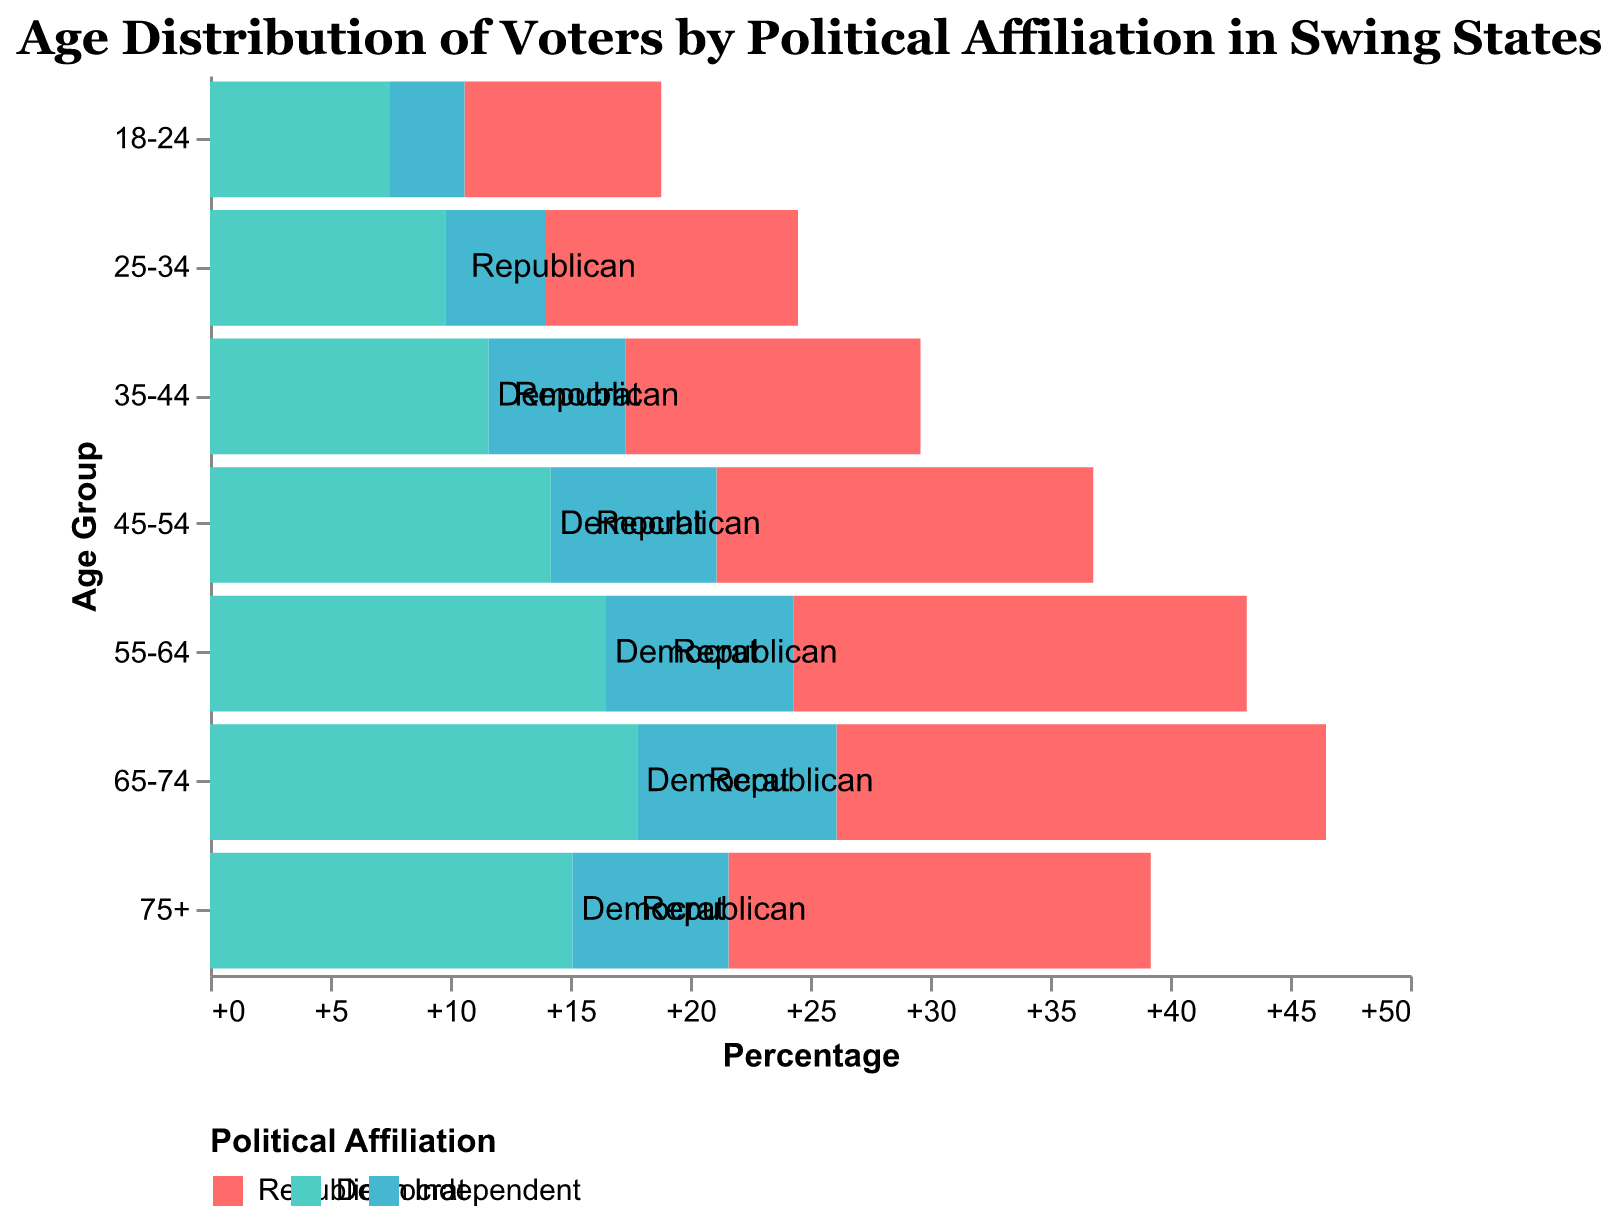What is the title of the graph? The title is displayed at the top of the graph. It clearly states the focus of the graph.
Answer: Age Distribution of Voters by Political Affiliation in Swing States What age group has the highest percentage of Republican voters? By examining the bar lengths representing Republicans, the length of the bar for the age group 65-74 is the longest.
Answer: 65-74 What age group has the lowest percentage of Democrat voters? By examining the bar lengths representing Democrats, the length of the bar for the age group 18-24 is the shortest.
Answer: 18-24 How does the percentage of Independent voters aged 35-44 compare to that of 75+? Check the lengths of the bars for Independents in the age categories 35-44 and 75+. The bar for 35-44 is longer than that for 75+.
Answer: Higher What is the difference in percentage of Democrat voters between the age groups 45-54 and 55-64? Look at the values for Democrat voters in these two age groups and subtract them. 16.5 (55-64) - 14.2 (45-54)
Answer: 2.3 Which political affiliation has the highest percentage of voters aged 25-34? Compare the lengths of the bars for Republican, Democrat, and Independent within the age group 25-34. The Democrat bar is the longest.
Answer: Democrat What is the sum of the percentages of Independent voters for the age groups 55-64 and 65-74? Add the values for Independent voters in these age groups: 7.8 (55-64) + 8.3 (65-74)
Answer: 16.1 Which age group shows the largest gap in voter percentage between Republicans and Democrats? Calculate the absolute difference between the lengths of the bars for Republicans and Democrats for each age group to identify the largest gap. This is the 65-74 group where the difference is 38.2 (20.4 + 17.8).
Answer: 65-74 What trend do we notice about Republican voter percentages as age increases? Observe the Republican percentages across the age groups. As the age increases, the percentage of Republican voters also increases until the 65-74 group.
Answer: Increasing What is the average percentage of Democrat voters across all age groups? Sum all the Democrat percentages and divide by the number of age groups: (7.5 + 9.8 + 11.6 + 14.2 + 16.5 + 17.8 + 15.1) / 7
Answer: 13.5 